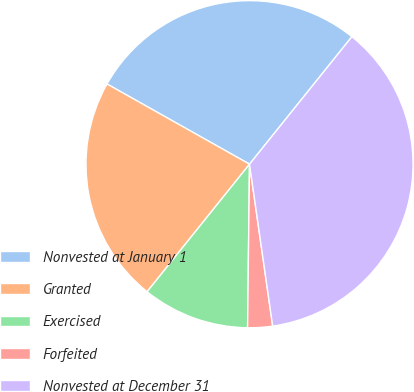<chart> <loc_0><loc_0><loc_500><loc_500><pie_chart><fcel>Nonvested at January 1<fcel>Granted<fcel>Exercised<fcel>Forfeited<fcel>Nonvested at December 31<nl><fcel>27.61%<fcel>22.39%<fcel>10.58%<fcel>2.45%<fcel>36.97%<nl></chart> 